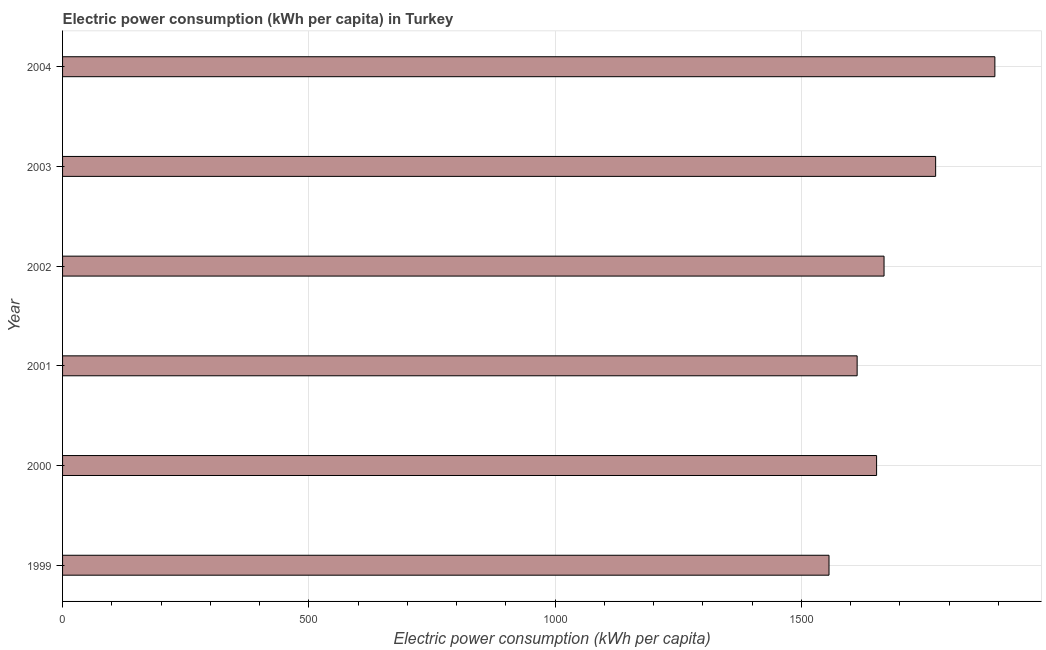Does the graph contain any zero values?
Provide a succinct answer. No. Does the graph contain grids?
Give a very brief answer. Yes. What is the title of the graph?
Make the answer very short. Electric power consumption (kWh per capita) in Turkey. What is the label or title of the X-axis?
Ensure brevity in your answer.  Electric power consumption (kWh per capita). What is the electric power consumption in 2002?
Offer a terse response. 1667.87. Across all years, what is the maximum electric power consumption?
Provide a succinct answer. 1892.9. Across all years, what is the minimum electric power consumption?
Your answer should be very brief. 1556.13. What is the sum of the electric power consumption?
Provide a succinct answer. 1.02e+04. What is the difference between the electric power consumption in 1999 and 2002?
Keep it short and to the point. -111.74. What is the average electric power consumption per year?
Make the answer very short. 1692.58. What is the median electric power consumption?
Provide a succinct answer. 1660.31. Do a majority of the years between 1999 and 2000 (inclusive) have electric power consumption greater than 1800 kWh per capita?
Offer a very short reply. No. What is the difference between the highest and the second highest electric power consumption?
Give a very brief answer. 120.28. What is the difference between the highest and the lowest electric power consumption?
Offer a very short reply. 336.77. How many bars are there?
Your answer should be compact. 6. Are all the bars in the graph horizontal?
Offer a terse response. Yes. Are the values on the major ticks of X-axis written in scientific E-notation?
Give a very brief answer. No. What is the Electric power consumption (kWh per capita) in 1999?
Make the answer very short. 1556.13. What is the Electric power consumption (kWh per capita) in 2000?
Ensure brevity in your answer.  1652.75. What is the Electric power consumption (kWh per capita) in 2001?
Offer a terse response. 1613.24. What is the Electric power consumption (kWh per capita) of 2002?
Offer a very short reply. 1667.87. What is the Electric power consumption (kWh per capita) of 2003?
Your response must be concise. 1772.61. What is the Electric power consumption (kWh per capita) of 2004?
Keep it short and to the point. 1892.9. What is the difference between the Electric power consumption (kWh per capita) in 1999 and 2000?
Give a very brief answer. -96.62. What is the difference between the Electric power consumption (kWh per capita) in 1999 and 2001?
Offer a terse response. -57.11. What is the difference between the Electric power consumption (kWh per capita) in 1999 and 2002?
Give a very brief answer. -111.74. What is the difference between the Electric power consumption (kWh per capita) in 1999 and 2003?
Make the answer very short. -216.48. What is the difference between the Electric power consumption (kWh per capita) in 1999 and 2004?
Your answer should be compact. -336.77. What is the difference between the Electric power consumption (kWh per capita) in 2000 and 2001?
Your response must be concise. 39.51. What is the difference between the Electric power consumption (kWh per capita) in 2000 and 2002?
Ensure brevity in your answer.  -15.12. What is the difference between the Electric power consumption (kWh per capita) in 2000 and 2003?
Give a very brief answer. -119.87. What is the difference between the Electric power consumption (kWh per capita) in 2000 and 2004?
Your answer should be very brief. -240.15. What is the difference between the Electric power consumption (kWh per capita) in 2001 and 2002?
Ensure brevity in your answer.  -54.63. What is the difference between the Electric power consumption (kWh per capita) in 2001 and 2003?
Your answer should be compact. -159.37. What is the difference between the Electric power consumption (kWh per capita) in 2001 and 2004?
Offer a terse response. -279.66. What is the difference between the Electric power consumption (kWh per capita) in 2002 and 2003?
Offer a very short reply. -104.75. What is the difference between the Electric power consumption (kWh per capita) in 2002 and 2004?
Keep it short and to the point. -225.03. What is the difference between the Electric power consumption (kWh per capita) in 2003 and 2004?
Provide a succinct answer. -120.28. What is the ratio of the Electric power consumption (kWh per capita) in 1999 to that in 2000?
Make the answer very short. 0.94. What is the ratio of the Electric power consumption (kWh per capita) in 1999 to that in 2002?
Make the answer very short. 0.93. What is the ratio of the Electric power consumption (kWh per capita) in 1999 to that in 2003?
Your response must be concise. 0.88. What is the ratio of the Electric power consumption (kWh per capita) in 1999 to that in 2004?
Your answer should be very brief. 0.82. What is the ratio of the Electric power consumption (kWh per capita) in 2000 to that in 2001?
Provide a short and direct response. 1.02. What is the ratio of the Electric power consumption (kWh per capita) in 2000 to that in 2003?
Offer a terse response. 0.93. What is the ratio of the Electric power consumption (kWh per capita) in 2000 to that in 2004?
Make the answer very short. 0.87. What is the ratio of the Electric power consumption (kWh per capita) in 2001 to that in 2002?
Offer a very short reply. 0.97. What is the ratio of the Electric power consumption (kWh per capita) in 2001 to that in 2003?
Offer a terse response. 0.91. What is the ratio of the Electric power consumption (kWh per capita) in 2001 to that in 2004?
Offer a terse response. 0.85. What is the ratio of the Electric power consumption (kWh per capita) in 2002 to that in 2003?
Provide a succinct answer. 0.94. What is the ratio of the Electric power consumption (kWh per capita) in 2002 to that in 2004?
Give a very brief answer. 0.88. What is the ratio of the Electric power consumption (kWh per capita) in 2003 to that in 2004?
Provide a short and direct response. 0.94. 